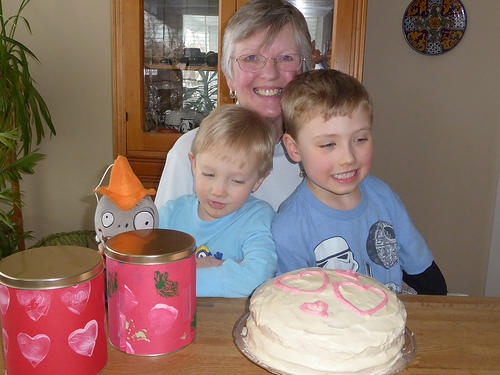<image>
Is the plush toy behind the tin? Yes. From this viewpoint, the plush toy is positioned behind the tin, with the tin partially or fully occluding the plush toy. Is there a cake in front of the boy? Yes. The cake is positioned in front of the boy, appearing closer to the camera viewpoint. 